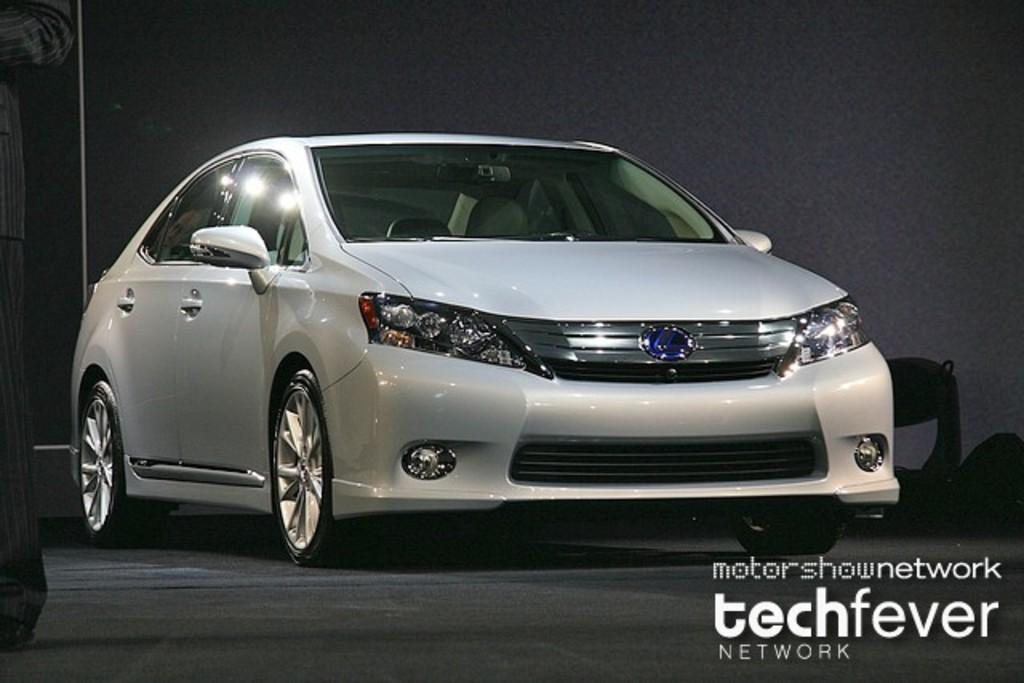What is the main subject of the image? The main subject of the image is a car. What are the car's features? The car has wheels. Can you describe the person in the image? There is a person on the left side of the image. Is there any additional information or markings in the image? There is a watermark on the right side bottom of the image. What type of pipe is being used by the person in the image? There is no pipe present in the image; it only features a car and a person. How many trucks are visible in the image? There are no trucks visible in the image; it only features a car. 